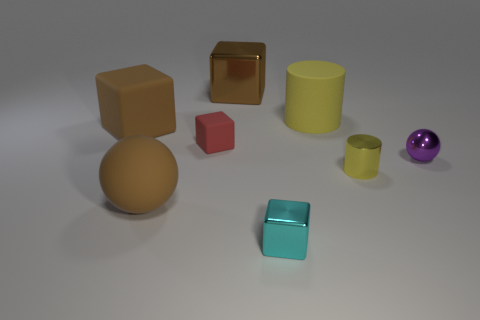Subtract 1 blocks. How many blocks are left? 3 Add 1 cubes. How many objects exist? 9 Subtract all spheres. How many objects are left? 6 Add 1 purple shiny balls. How many purple shiny balls are left? 2 Add 6 metallic cubes. How many metallic cubes exist? 8 Subtract 1 brown balls. How many objects are left? 7 Subtract all big purple things. Subtract all metallic balls. How many objects are left? 7 